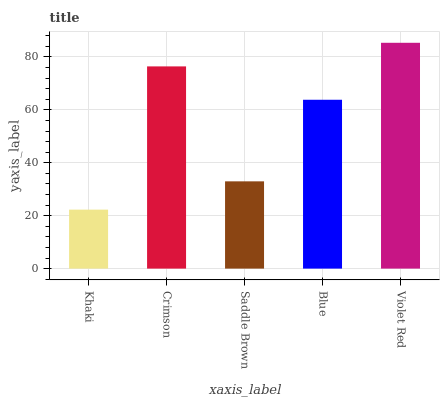Is Khaki the minimum?
Answer yes or no. Yes. Is Violet Red the maximum?
Answer yes or no. Yes. Is Crimson the minimum?
Answer yes or no. No. Is Crimson the maximum?
Answer yes or no. No. Is Crimson greater than Khaki?
Answer yes or no. Yes. Is Khaki less than Crimson?
Answer yes or no. Yes. Is Khaki greater than Crimson?
Answer yes or no. No. Is Crimson less than Khaki?
Answer yes or no. No. Is Blue the high median?
Answer yes or no. Yes. Is Blue the low median?
Answer yes or no. Yes. Is Saddle Brown the high median?
Answer yes or no. No. Is Khaki the low median?
Answer yes or no. No. 